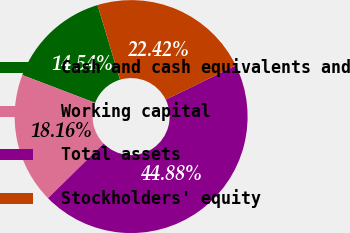Convert chart to OTSL. <chart><loc_0><loc_0><loc_500><loc_500><pie_chart><fcel>Cash and cash equivalents and<fcel>Working capital<fcel>Total assets<fcel>Stockholders' equity<nl><fcel>14.54%<fcel>18.16%<fcel>44.88%<fcel>22.42%<nl></chart> 